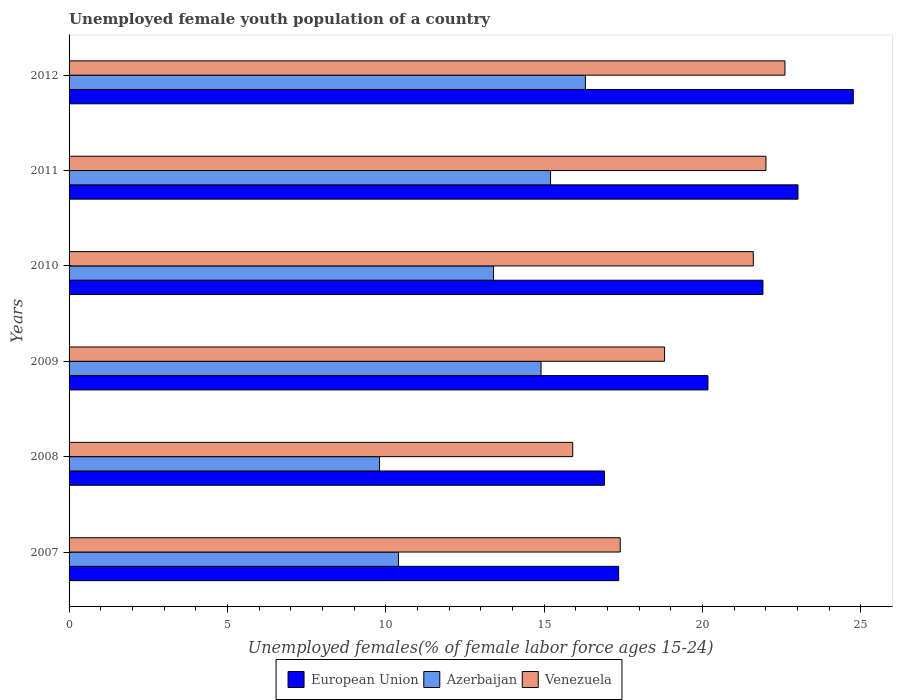How many groups of bars are there?
Provide a short and direct response. 6. How many bars are there on the 2nd tick from the top?
Your answer should be very brief. 3. How many bars are there on the 4th tick from the bottom?
Provide a succinct answer. 3. What is the label of the 4th group of bars from the top?
Your answer should be very brief. 2009. In how many cases, is the number of bars for a given year not equal to the number of legend labels?
Provide a short and direct response. 0. What is the percentage of unemployed female youth population in Azerbaijan in 2007?
Make the answer very short. 10.4. Across all years, what is the maximum percentage of unemployed female youth population in Azerbaijan?
Offer a very short reply. 16.3. Across all years, what is the minimum percentage of unemployed female youth population in European Union?
Ensure brevity in your answer.  16.9. In which year was the percentage of unemployed female youth population in Venezuela maximum?
Offer a very short reply. 2012. In which year was the percentage of unemployed female youth population in European Union minimum?
Offer a terse response. 2008. What is the total percentage of unemployed female youth population in Venezuela in the graph?
Your answer should be compact. 118.3. What is the difference between the percentage of unemployed female youth population in European Union in 2009 and the percentage of unemployed female youth population in Azerbaijan in 2012?
Give a very brief answer. 3.87. What is the average percentage of unemployed female youth population in Venezuela per year?
Provide a succinct answer. 19.72. In the year 2009, what is the difference between the percentage of unemployed female youth population in European Union and percentage of unemployed female youth population in Venezuela?
Your answer should be compact. 1.37. In how many years, is the percentage of unemployed female youth population in European Union greater than 16 %?
Offer a very short reply. 6. What is the ratio of the percentage of unemployed female youth population in Venezuela in 2007 to that in 2012?
Offer a very short reply. 0.77. Is the difference between the percentage of unemployed female youth population in European Union in 2010 and 2011 greater than the difference between the percentage of unemployed female youth population in Venezuela in 2010 and 2011?
Make the answer very short. No. What is the difference between the highest and the second highest percentage of unemployed female youth population in Venezuela?
Give a very brief answer. 0.6. What is the difference between the highest and the lowest percentage of unemployed female youth population in Azerbaijan?
Give a very brief answer. 6.5. In how many years, is the percentage of unemployed female youth population in European Union greater than the average percentage of unemployed female youth population in European Union taken over all years?
Provide a short and direct response. 3. Is the sum of the percentage of unemployed female youth population in European Union in 2009 and 2011 greater than the maximum percentage of unemployed female youth population in Azerbaijan across all years?
Your response must be concise. Yes. What does the 1st bar from the top in 2009 represents?
Ensure brevity in your answer.  Venezuela. Is it the case that in every year, the sum of the percentage of unemployed female youth population in European Union and percentage of unemployed female youth population in Venezuela is greater than the percentage of unemployed female youth population in Azerbaijan?
Make the answer very short. Yes. How many bars are there?
Provide a succinct answer. 18. Are all the bars in the graph horizontal?
Your answer should be compact. Yes. How many years are there in the graph?
Offer a terse response. 6. Are the values on the major ticks of X-axis written in scientific E-notation?
Provide a short and direct response. No. Does the graph contain any zero values?
Provide a succinct answer. No. How are the legend labels stacked?
Your response must be concise. Horizontal. What is the title of the graph?
Offer a terse response. Unemployed female youth population of a country. What is the label or title of the X-axis?
Keep it short and to the point. Unemployed females(% of female labor force ages 15-24). What is the Unemployed females(% of female labor force ages 15-24) of European Union in 2007?
Your answer should be compact. 17.35. What is the Unemployed females(% of female labor force ages 15-24) in Azerbaijan in 2007?
Make the answer very short. 10.4. What is the Unemployed females(% of female labor force ages 15-24) in Venezuela in 2007?
Ensure brevity in your answer.  17.4. What is the Unemployed females(% of female labor force ages 15-24) of European Union in 2008?
Your answer should be compact. 16.9. What is the Unemployed females(% of female labor force ages 15-24) in Azerbaijan in 2008?
Keep it short and to the point. 9.8. What is the Unemployed females(% of female labor force ages 15-24) in Venezuela in 2008?
Your response must be concise. 15.9. What is the Unemployed females(% of female labor force ages 15-24) of European Union in 2009?
Your answer should be very brief. 20.17. What is the Unemployed females(% of female labor force ages 15-24) in Azerbaijan in 2009?
Your response must be concise. 14.9. What is the Unemployed females(% of female labor force ages 15-24) in Venezuela in 2009?
Offer a terse response. 18.8. What is the Unemployed females(% of female labor force ages 15-24) of European Union in 2010?
Make the answer very short. 21.91. What is the Unemployed females(% of female labor force ages 15-24) in Azerbaijan in 2010?
Make the answer very short. 13.4. What is the Unemployed females(% of female labor force ages 15-24) in Venezuela in 2010?
Keep it short and to the point. 21.6. What is the Unemployed females(% of female labor force ages 15-24) of European Union in 2011?
Keep it short and to the point. 23.01. What is the Unemployed females(% of female labor force ages 15-24) of Azerbaijan in 2011?
Provide a succinct answer. 15.2. What is the Unemployed females(% of female labor force ages 15-24) in Venezuela in 2011?
Your answer should be very brief. 22. What is the Unemployed females(% of female labor force ages 15-24) in European Union in 2012?
Provide a succinct answer. 24.76. What is the Unemployed females(% of female labor force ages 15-24) in Azerbaijan in 2012?
Your answer should be very brief. 16.3. What is the Unemployed females(% of female labor force ages 15-24) of Venezuela in 2012?
Provide a short and direct response. 22.6. Across all years, what is the maximum Unemployed females(% of female labor force ages 15-24) in European Union?
Keep it short and to the point. 24.76. Across all years, what is the maximum Unemployed females(% of female labor force ages 15-24) of Azerbaijan?
Offer a terse response. 16.3. Across all years, what is the maximum Unemployed females(% of female labor force ages 15-24) in Venezuela?
Offer a very short reply. 22.6. Across all years, what is the minimum Unemployed females(% of female labor force ages 15-24) in European Union?
Ensure brevity in your answer.  16.9. Across all years, what is the minimum Unemployed females(% of female labor force ages 15-24) of Azerbaijan?
Keep it short and to the point. 9.8. Across all years, what is the minimum Unemployed females(% of female labor force ages 15-24) of Venezuela?
Your answer should be very brief. 15.9. What is the total Unemployed females(% of female labor force ages 15-24) of European Union in the graph?
Offer a very short reply. 124.09. What is the total Unemployed females(% of female labor force ages 15-24) of Azerbaijan in the graph?
Ensure brevity in your answer.  80. What is the total Unemployed females(% of female labor force ages 15-24) in Venezuela in the graph?
Offer a very short reply. 118.3. What is the difference between the Unemployed females(% of female labor force ages 15-24) of European Union in 2007 and that in 2008?
Provide a succinct answer. 0.45. What is the difference between the Unemployed females(% of female labor force ages 15-24) of Venezuela in 2007 and that in 2008?
Your answer should be compact. 1.5. What is the difference between the Unemployed females(% of female labor force ages 15-24) in European Union in 2007 and that in 2009?
Ensure brevity in your answer.  -2.82. What is the difference between the Unemployed females(% of female labor force ages 15-24) in Venezuela in 2007 and that in 2009?
Provide a short and direct response. -1.4. What is the difference between the Unemployed females(% of female labor force ages 15-24) of European Union in 2007 and that in 2010?
Your answer should be compact. -4.55. What is the difference between the Unemployed females(% of female labor force ages 15-24) in Venezuela in 2007 and that in 2010?
Make the answer very short. -4.2. What is the difference between the Unemployed females(% of female labor force ages 15-24) of European Union in 2007 and that in 2011?
Ensure brevity in your answer.  -5.66. What is the difference between the Unemployed females(% of female labor force ages 15-24) in Azerbaijan in 2007 and that in 2011?
Provide a succinct answer. -4.8. What is the difference between the Unemployed females(% of female labor force ages 15-24) in Venezuela in 2007 and that in 2011?
Provide a succinct answer. -4.6. What is the difference between the Unemployed females(% of female labor force ages 15-24) in European Union in 2007 and that in 2012?
Keep it short and to the point. -7.41. What is the difference between the Unemployed females(% of female labor force ages 15-24) in European Union in 2008 and that in 2009?
Your response must be concise. -3.27. What is the difference between the Unemployed females(% of female labor force ages 15-24) of European Union in 2008 and that in 2010?
Make the answer very short. -5. What is the difference between the Unemployed females(% of female labor force ages 15-24) in Venezuela in 2008 and that in 2010?
Your answer should be very brief. -5.7. What is the difference between the Unemployed females(% of female labor force ages 15-24) in European Union in 2008 and that in 2011?
Keep it short and to the point. -6.11. What is the difference between the Unemployed females(% of female labor force ages 15-24) of Venezuela in 2008 and that in 2011?
Offer a terse response. -6.1. What is the difference between the Unemployed females(% of female labor force ages 15-24) in European Union in 2008 and that in 2012?
Ensure brevity in your answer.  -7.86. What is the difference between the Unemployed females(% of female labor force ages 15-24) in Azerbaijan in 2008 and that in 2012?
Offer a very short reply. -6.5. What is the difference between the Unemployed females(% of female labor force ages 15-24) in Venezuela in 2008 and that in 2012?
Make the answer very short. -6.7. What is the difference between the Unemployed females(% of female labor force ages 15-24) of European Union in 2009 and that in 2010?
Give a very brief answer. -1.74. What is the difference between the Unemployed females(% of female labor force ages 15-24) of Azerbaijan in 2009 and that in 2010?
Give a very brief answer. 1.5. What is the difference between the Unemployed females(% of female labor force ages 15-24) in European Union in 2009 and that in 2011?
Provide a succinct answer. -2.84. What is the difference between the Unemployed females(% of female labor force ages 15-24) of Venezuela in 2009 and that in 2011?
Provide a succinct answer. -3.2. What is the difference between the Unemployed females(% of female labor force ages 15-24) in European Union in 2009 and that in 2012?
Offer a terse response. -4.59. What is the difference between the Unemployed females(% of female labor force ages 15-24) of Azerbaijan in 2009 and that in 2012?
Your answer should be compact. -1.4. What is the difference between the Unemployed females(% of female labor force ages 15-24) in European Union in 2010 and that in 2011?
Give a very brief answer. -1.11. What is the difference between the Unemployed females(% of female labor force ages 15-24) of Azerbaijan in 2010 and that in 2011?
Ensure brevity in your answer.  -1.8. What is the difference between the Unemployed females(% of female labor force ages 15-24) of Venezuela in 2010 and that in 2011?
Your response must be concise. -0.4. What is the difference between the Unemployed females(% of female labor force ages 15-24) of European Union in 2010 and that in 2012?
Keep it short and to the point. -2.85. What is the difference between the Unemployed females(% of female labor force ages 15-24) in European Union in 2011 and that in 2012?
Your answer should be compact. -1.75. What is the difference between the Unemployed females(% of female labor force ages 15-24) in European Union in 2007 and the Unemployed females(% of female labor force ages 15-24) in Azerbaijan in 2008?
Keep it short and to the point. 7.55. What is the difference between the Unemployed females(% of female labor force ages 15-24) of European Union in 2007 and the Unemployed females(% of female labor force ages 15-24) of Venezuela in 2008?
Offer a very short reply. 1.45. What is the difference between the Unemployed females(% of female labor force ages 15-24) of European Union in 2007 and the Unemployed females(% of female labor force ages 15-24) of Azerbaijan in 2009?
Ensure brevity in your answer.  2.45. What is the difference between the Unemployed females(% of female labor force ages 15-24) in European Union in 2007 and the Unemployed females(% of female labor force ages 15-24) in Venezuela in 2009?
Your answer should be very brief. -1.45. What is the difference between the Unemployed females(% of female labor force ages 15-24) of Azerbaijan in 2007 and the Unemployed females(% of female labor force ages 15-24) of Venezuela in 2009?
Your answer should be very brief. -8.4. What is the difference between the Unemployed females(% of female labor force ages 15-24) in European Union in 2007 and the Unemployed females(% of female labor force ages 15-24) in Azerbaijan in 2010?
Offer a very short reply. 3.95. What is the difference between the Unemployed females(% of female labor force ages 15-24) in European Union in 2007 and the Unemployed females(% of female labor force ages 15-24) in Venezuela in 2010?
Keep it short and to the point. -4.25. What is the difference between the Unemployed females(% of female labor force ages 15-24) in Azerbaijan in 2007 and the Unemployed females(% of female labor force ages 15-24) in Venezuela in 2010?
Keep it short and to the point. -11.2. What is the difference between the Unemployed females(% of female labor force ages 15-24) of European Union in 2007 and the Unemployed females(% of female labor force ages 15-24) of Azerbaijan in 2011?
Your response must be concise. 2.15. What is the difference between the Unemployed females(% of female labor force ages 15-24) of European Union in 2007 and the Unemployed females(% of female labor force ages 15-24) of Venezuela in 2011?
Offer a very short reply. -4.65. What is the difference between the Unemployed females(% of female labor force ages 15-24) in European Union in 2007 and the Unemployed females(% of female labor force ages 15-24) in Azerbaijan in 2012?
Offer a very short reply. 1.05. What is the difference between the Unemployed females(% of female labor force ages 15-24) in European Union in 2007 and the Unemployed females(% of female labor force ages 15-24) in Venezuela in 2012?
Provide a succinct answer. -5.25. What is the difference between the Unemployed females(% of female labor force ages 15-24) of European Union in 2008 and the Unemployed females(% of female labor force ages 15-24) of Azerbaijan in 2009?
Your answer should be very brief. 2. What is the difference between the Unemployed females(% of female labor force ages 15-24) in European Union in 2008 and the Unemployed females(% of female labor force ages 15-24) in Venezuela in 2009?
Provide a short and direct response. -1.9. What is the difference between the Unemployed females(% of female labor force ages 15-24) of European Union in 2008 and the Unemployed females(% of female labor force ages 15-24) of Azerbaijan in 2010?
Your answer should be very brief. 3.5. What is the difference between the Unemployed females(% of female labor force ages 15-24) in European Union in 2008 and the Unemployed females(% of female labor force ages 15-24) in Venezuela in 2010?
Provide a succinct answer. -4.7. What is the difference between the Unemployed females(% of female labor force ages 15-24) of European Union in 2008 and the Unemployed females(% of female labor force ages 15-24) of Azerbaijan in 2011?
Your answer should be very brief. 1.7. What is the difference between the Unemployed females(% of female labor force ages 15-24) in European Union in 2008 and the Unemployed females(% of female labor force ages 15-24) in Venezuela in 2011?
Offer a terse response. -5.1. What is the difference between the Unemployed females(% of female labor force ages 15-24) in European Union in 2008 and the Unemployed females(% of female labor force ages 15-24) in Azerbaijan in 2012?
Give a very brief answer. 0.6. What is the difference between the Unemployed females(% of female labor force ages 15-24) in European Union in 2008 and the Unemployed females(% of female labor force ages 15-24) in Venezuela in 2012?
Provide a short and direct response. -5.7. What is the difference between the Unemployed females(% of female labor force ages 15-24) in European Union in 2009 and the Unemployed females(% of female labor force ages 15-24) in Azerbaijan in 2010?
Offer a very short reply. 6.77. What is the difference between the Unemployed females(% of female labor force ages 15-24) of European Union in 2009 and the Unemployed females(% of female labor force ages 15-24) of Venezuela in 2010?
Provide a succinct answer. -1.43. What is the difference between the Unemployed females(% of female labor force ages 15-24) of European Union in 2009 and the Unemployed females(% of female labor force ages 15-24) of Azerbaijan in 2011?
Provide a short and direct response. 4.97. What is the difference between the Unemployed females(% of female labor force ages 15-24) of European Union in 2009 and the Unemployed females(% of female labor force ages 15-24) of Venezuela in 2011?
Offer a very short reply. -1.83. What is the difference between the Unemployed females(% of female labor force ages 15-24) in European Union in 2009 and the Unemployed females(% of female labor force ages 15-24) in Azerbaijan in 2012?
Keep it short and to the point. 3.87. What is the difference between the Unemployed females(% of female labor force ages 15-24) in European Union in 2009 and the Unemployed females(% of female labor force ages 15-24) in Venezuela in 2012?
Keep it short and to the point. -2.43. What is the difference between the Unemployed females(% of female labor force ages 15-24) in Azerbaijan in 2009 and the Unemployed females(% of female labor force ages 15-24) in Venezuela in 2012?
Provide a succinct answer. -7.7. What is the difference between the Unemployed females(% of female labor force ages 15-24) in European Union in 2010 and the Unemployed females(% of female labor force ages 15-24) in Azerbaijan in 2011?
Make the answer very short. 6.71. What is the difference between the Unemployed females(% of female labor force ages 15-24) of European Union in 2010 and the Unemployed females(% of female labor force ages 15-24) of Venezuela in 2011?
Offer a terse response. -0.1. What is the difference between the Unemployed females(% of female labor force ages 15-24) of European Union in 2010 and the Unemployed females(% of female labor force ages 15-24) of Azerbaijan in 2012?
Make the answer very short. 5.61. What is the difference between the Unemployed females(% of female labor force ages 15-24) in European Union in 2010 and the Unemployed females(% of female labor force ages 15-24) in Venezuela in 2012?
Ensure brevity in your answer.  -0.69. What is the difference between the Unemployed females(% of female labor force ages 15-24) of European Union in 2011 and the Unemployed females(% of female labor force ages 15-24) of Azerbaijan in 2012?
Offer a terse response. 6.71. What is the difference between the Unemployed females(% of female labor force ages 15-24) in European Union in 2011 and the Unemployed females(% of female labor force ages 15-24) in Venezuela in 2012?
Give a very brief answer. 0.41. What is the average Unemployed females(% of female labor force ages 15-24) in European Union per year?
Your answer should be compact. 20.68. What is the average Unemployed females(% of female labor force ages 15-24) of Azerbaijan per year?
Keep it short and to the point. 13.33. What is the average Unemployed females(% of female labor force ages 15-24) of Venezuela per year?
Give a very brief answer. 19.72. In the year 2007, what is the difference between the Unemployed females(% of female labor force ages 15-24) of European Union and Unemployed females(% of female labor force ages 15-24) of Azerbaijan?
Give a very brief answer. 6.95. In the year 2007, what is the difference between the Unemployed females(% of female labor force ages 15-24) of European Union and Unemployed females(% of female labor force ages 15-24) of Venezuela?
Your answer should be compact. -0.05. In the year 2007, what is the difference between the Unemployed females(% of female labor force ages 15-24) of Azerbaijan and Unemployed females(% of female labor force ages 15-24) of Venezuela?
Give a very brief answer. -7. In the year 2008, what is the difference between the Unemployed females(% of female labor force ages 15-24) in European Union and Unemployed females(% of female labor force ages 15-24) in Azerbaijan?
Keep it short and to the point. 7.1. In the year 2008, what is the difference between the Unemployed females(% of female labor force ages 15-24) of European Union and Unemployed females(% of female labor force ages 15-24) of Venezuela?
Offer a very short reply. 1. In the year 2009, what is the difference between the Unemployed females(% of female labor force ages 15-24) in European Union and Unemployed females(% of female labor force ages 15-24) in Azerbaijan?
Ensure brevity in your answer.  5.27. In the year 2009, what is the difference between the Unemployed females(% of female labor force ages 15-24) in European Union and Unemployed females(% of female labor force ages 15-24) in Venezuela?
Offer a terse response. 1.37. In the year 2010, what is the difference between the Unemployed females(% of female labor force ages 15-24) of European Union and Unemployed females(% of female labor force ages 15-24) of Azerbaijan?
Provide a short and direct response. 8.51. In the year 2010, what is the difference between the Unemployed females(% of female labor force ages 15-24) in European Union and Unemployed females(% of female labor force ages 15-24) in Venezuela?
Offer a very short reply. 0.3. In the year 2010, what is the difference between the Unemployed females(% of female labor force ages 15-24) in Azerbaijan and Unemployed females(% of female labor force ages 15-24) in Venezuela?
Keep it short and to the point. -8.2. In the year 2011, what is the difference between the Unemployed females(% of female labor force ages 15-24) of European Union and Unemployed females(% of female labor force ages 15-24) of Azerbaijan?
Provide a succinct answer. 7.81. In the year 2011, what is the difference between the Unemployed females(% of female labor force ages 15-24) of European Union and Unemployed females(% of female labor force ages 15-24) of Venezuela?
Your response must be concise. 1.01. In the year 2012, what is the difference between the Unemployed females(% of female labor force ages 15-24) in European Union and Unemployed females(% of female labor force ages 15-24) in Azerbaijan?
Give a very brief answer. 8.46. In the year 2012, what is the difference between the Unemployed females(% of female labor force ages 15-24) of European Union and Unemployed females(% of female labor force ages 15-24) of Venezuela?
Your response must be concise. 2.16. In the year 2012, what is the difference between the Unemployed females(% of female labor force ages 15-24) in Azerbaijan and Unemployed females(% of female labor force ages 15-24) in Venezuela?
Keep it short and to the point. -6.3. What is the ratio of the Unemployed females(% of female labor force ages 15-24) in European Union in 2007 to that in 2008?
Give a very brief answer. 1.03. What is the ratio of the Unemployed females(% of female labor force ages 15-24) of Azerbaijan in 2007 to that in 2008?
Provide a succinct answer. 1.06. What is the ratio of the Unemployed females(% of female labor force ages 15-24) of Venezuela in 2007 to that in 2008?
Your answer should be compact. 1.09. What is the ratio of the Unemployed females(% of female labor force ages 15-24) in European Union in 2007 to that in 2009?
Provide a short and direct response. 0.86. What is the ratio of the Unemployed females(% of female labor force ages 15-24) of Azerbaijan in 2007 to that in 2009?
Offer a very short reply. 0.7. What is the ratio of the Unemployed females(% of female labor force ages 15-24) in Venezuela in 2007 to that in 2009?
Offer a very short reply. 0.93. What is the ratio of the Unemployed females(% of female labor force ages 15-24) of European Union in 2007 to that in 2010?
Your answer should be compact. 0.79. What is the ratio of the Unemployed females(% of female labor force ages 15-24) in Azerbaijan in 2007 to that in 2010?
Keep it short and to the point. 0.78. What is the ratio of the Unemployed females(% of female labor force ages 15-24) of Venezuela in 2007 to that in 2010?
Ensure brevity in your answer.  0.81. What is the ratio of the Unemployed females(% of female labor force ages 15-24) of European Union in 2007 to that in 2011?
Ensure brevity in your answer.  0.75. What is the ratio of the Unemployed females(% of female labor force ages 15-24) in Azerbaijan in 2007 to that in 2011?
Offer a terse response. 0.68. What is the ratio of the Unemployed females(% of female labor force ages 15-24) of Venezuela in 2007 to that in 2011?
Ensure brevity in your answer.  0.79. What is the ratio of the Unemployed females(% of female labor force ages 15-24) of European Union in 2007 to that in 2012?
Offer a very short reply. 0.7. What is the ratio of the Unemployed females(% of female labor force ages 15-24) of Azerbaijan in 2007 to that in 2012?
Make the answer very short. 0.64. What is the ratio of the Unemployed females(% of female labor force ages 15-24) of Venezuela in 2007 to that in 2012?
Offer a terse response. 0.77. What is the ratio of the Unemployed females(% of female labor force ages 15-24) of European Union in 2008 to that in 2009?
Provide a short and direct response. 0.84. What is the ratio of the Unemployed females(% of female labor force ages 15-24) in Azerbaijan in 2008 to that in 2009?
Provide a short and direct response. 0.66. What is the ratio of the Unemployed females(% of female labor force ages 15-24) of Venezuela in 2008 to that in 2009?
Provide a succinct answer. 0.85. What is the ratio of the Unemployed females(% of female labor force ages 15-24) in European Union in 2008 to that in 2010?
Offer a very short reply. 0.77. What is the ratio of the Unemployed females(% of female labor force ages 15-24) in Azerbaijan in 2008 to that in 2010?
Your answer should be compact. 0.73. What is the ratio of the Unemployed females(% of female labor force ages 15-24) in Venezuela in 2008 to that in 2010?
Make the answer very short. 0.74. What is the ratio of the Unemployed females(% of female labor force ages 15-24) in European Union in 2008 to that in 2011?
Make the answer very short. 0.73. What is the ratio of the Unemployed females(% of female labor force ages 15-24) of Azerbaijan in 2008 to that in 2011?
Your answer should be very brief. 0.64. What is the ratio of the Unemployed females(% of female labor force ages 15-24) in Venezuela in 2008 to that in 2011?
Give a very brief answer. 0.72. What is the ratio of the Unemployed females(% of female labor force ages 15-24) of European Union in 2008 to that in 2012?
Offer a terse response. 0.68. What is the ratio of the Unemployed females(% of female labor force ages 15-24) in Azerbaijan in 2008 to that in 2012?
Ensure brevity in your answer.  0.6. What is the ratio of the Unemployed females(% of female labor force ages 15-24) in Venezuela in 2008 to that in 2012?
Provide a succinct answer. 0.7. What is the ratio of the Unemployed females(% of female labor force ages 15-24) of European Union in 2009 to that in 2010?
Ensure brevity in your answer.  0.92. What is the ratio of the Unemployed females(% of female labor force ages 15-24) in Azerbaijan in 2009 to that in 2010?
Provide a succinct answer. 1.11. What is the ratio of the Unemployed females(% of female labor force ages 15-24) of Venezuela in 2009 to that in 2010?
Keep it short and to the point. 0.87. What is the ratio of the Unemployed females(% of female labor force ages 15-24) in European Union in 2009 to that in 2011?
Provide a short and direct response. 0.88. What is the ratio of the Unemployed females(% of female labor force ages 15-24) of Azerbaijan in 2009 to that in 2011?
Keep it short and to the point. 0.98. What is the ratio of the Unemployed females(% of female labor force ages 15-24) of Venezuela in 2009 to that in 2011?
Your response must be concise. 0.85. What is the ratio of the Unemployed females(% of female labor force ages 15-24) in European Union in 2009 to that in 2012?
Keep it short and to the point. 0.81. What is the ratio of the Unemployed females(% of female labor force ages 15-24) of Azerbaijan in 2009 to that in 2012?
Make the answer very short. 0.91. What is the ratio of the Unemployed females(% of female labor force ages 15-24) of Venezuela in 2009 to that in 2012?
Your answer should be very brief. 0.83. What is the ratio of the Unemployed females(% of female labor force ages 15-24) of European Union in 2010 to that in 2011?
Your answer should be very brief. 0.95. What is the ratio of the Unemployed females(% of female labor force ages 15-24) in Azerbaijan in 2010 to that in 2011?
Offer a very short reply. 0.88. What is the ratio of the Unemployed females(% of female labor force ages 15-24) in Venezuela in 2010 to that in 2011?
Keep it short and to the point. 0.98. What is the ratio of the Unemployed females(% of female labor force ages 15-24) of European Union in 2010 to that in 2012?
Keep it short and to the point. 0.88. What is the ratio of the Unemployed females(% of female labor force ages 15-24) in Azerbaijan in 2010 to that in 2012?
Offer a terse response. 0.82. What is the ratio of the Unemployed females(% of female labor force ages 15-24) in Venezuela in 2010 to that in 2012?
Provide a succinct answer. 0.96. What is the ratio of the Unemployed females(% of female labor force ages 15-24) of European Union in 2011 to that in 2012?
Keep it short and to the point. 0.93. What is the ratio of the Unemployed females(% of female labor force ages 15-24) in Azerbaijan in 2011 to that in 2012?
Your answer should be compact. 0.93. What is the ratio of the Unemployed females(% of female labor force ages 15-24) in Venezuela in 2011 to that in 2012?
Provide a succinct answer. 0.97. What is the difference between the highest and the second highest Unemployed females(% of female labor force ages 15-24) of European Union?
Keep it short and to the point. 1.75. What is the difference between the highest and the second highest Unemployed females(% of female labor force ages 15-24) in Azerbaijan?
Give a very brief answer. 1.1. What is the difference between the highest and the lowest Unemployed females(% of female labor force ages 15-24) in European Union?
Offer a terse response. 7.86. 